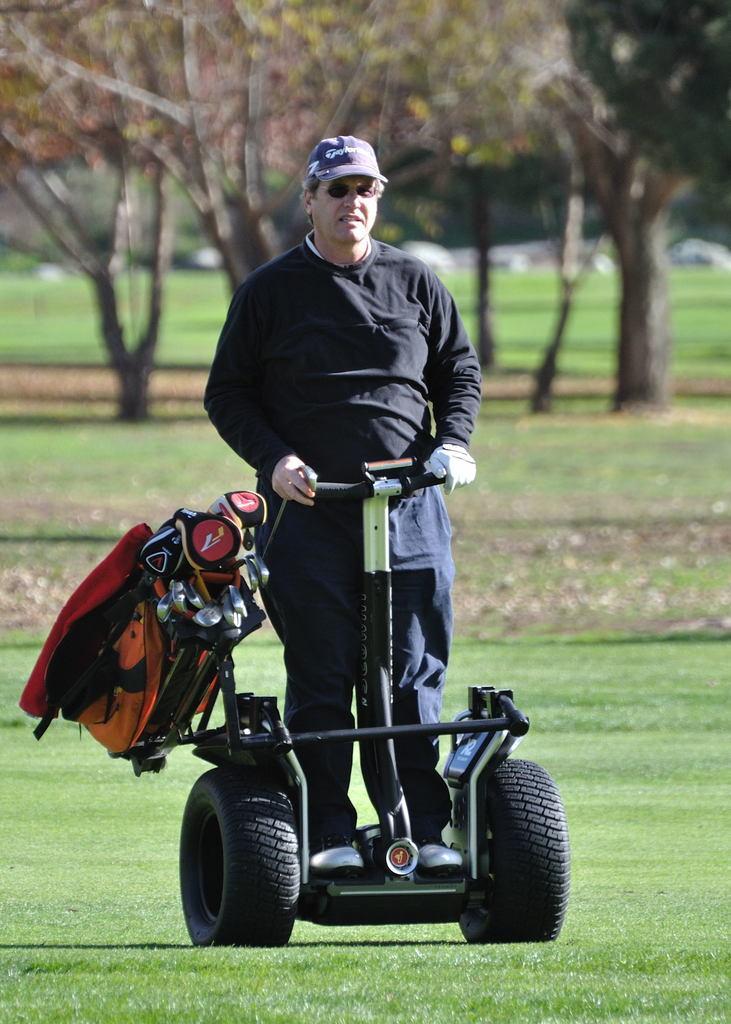Can you describe this image briefly? In this image we can see a person wearing specs, cab and a glove. He is standing on a segway. On the ground there is grass. In the background there are trees. On the segway there is a bag. 